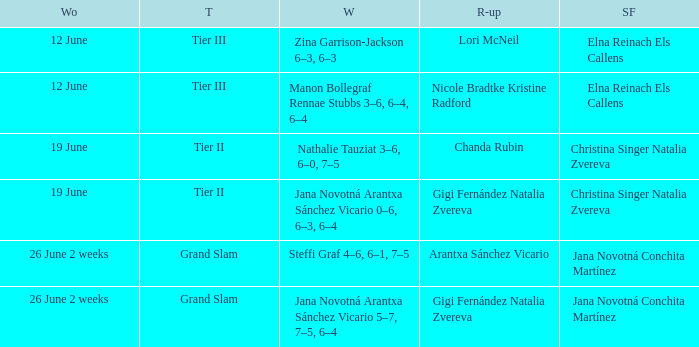Could you parse the entire table? {'header': ['Wo', 'T', 'W', 'R-up', 'SF'], 'rows': [['12 June', 'Tier III', 'Zina Garrison-Jackson 6–3, 6–3', 'Lori McNeil', 'Elna Reinach Els Callens'], ['12 June', 'Tier III', 'Manon Bollegraf Rennae Stubbs 3–6, 6–4, 6–4', 'Nicole Bradtke Kristine Radford', 'Elna Reinach Els Callens'], ['19 June', 'Tier II', 'Nathalie Tauziat 3–6, 6–0, 7–5', 'Chanda Rubin', 'Christina Singer Natalia Zvereva'], ['19 June', 'Tier II', 'Jana Novotná Arantxa Sánchez Vicario 0–6, 6–3, 6–4', 'Gigi Fernández Natalia Zvereva', 'Christina Singer Natalia Zvereva'], ['26 June 2 weeks', 'Grand Slam', 'Steffi Graf 4–6, 6–1, 7–5', 'Arantxa Sánchez Vicario', 'Jana Novotná Conchita Martínez'], ['26 June 2 weeks', 'Grand Slam', 'Jana Novotná Arantxa Sánchez Vicario 5–7, 7–5, 6–4', 'Gigi Fernández Natalia Zvereva', 'Jana Novotná Conchita Martínez']]} When the runner-up is listed as Gigi Fernández Natalia Zvereva and the week is 26 June 2 weeks, who are the semi finalists? Jana Novotná Conchita Martínez. 